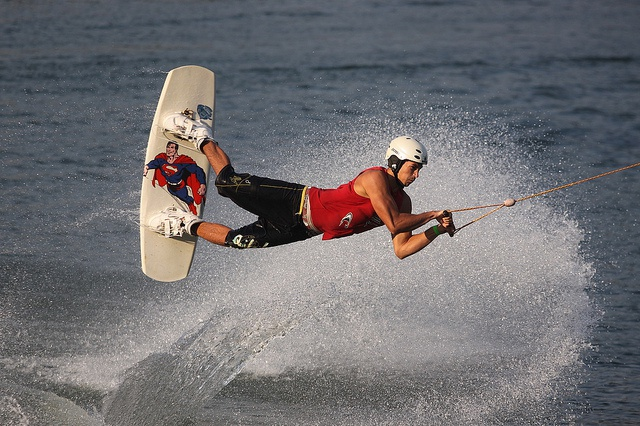Describe the objects in this image and their specific colors. I can see people in gray, black, brown, maroon, and beige tones and surfboard in gray and tan tones in this image. 